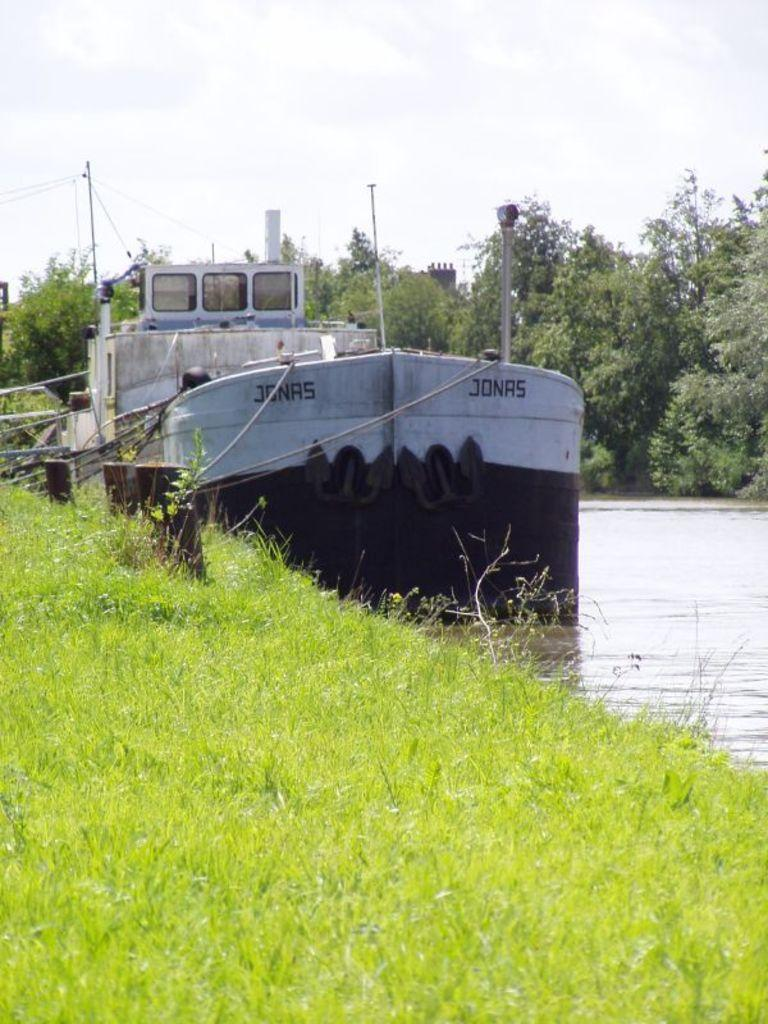What is the main subject of the image? The main subject of the image is a boat. Where is the boat located? The boat is on the water. What can be seen on the left side of the image? There is grass on the left side of the image. What is visible in the background of the image? There are trees and clouds in the sky in the background of the image. What is the value of the eggnog in the image? There is no eggnog present in the image, so it is not possible to determine its value. 